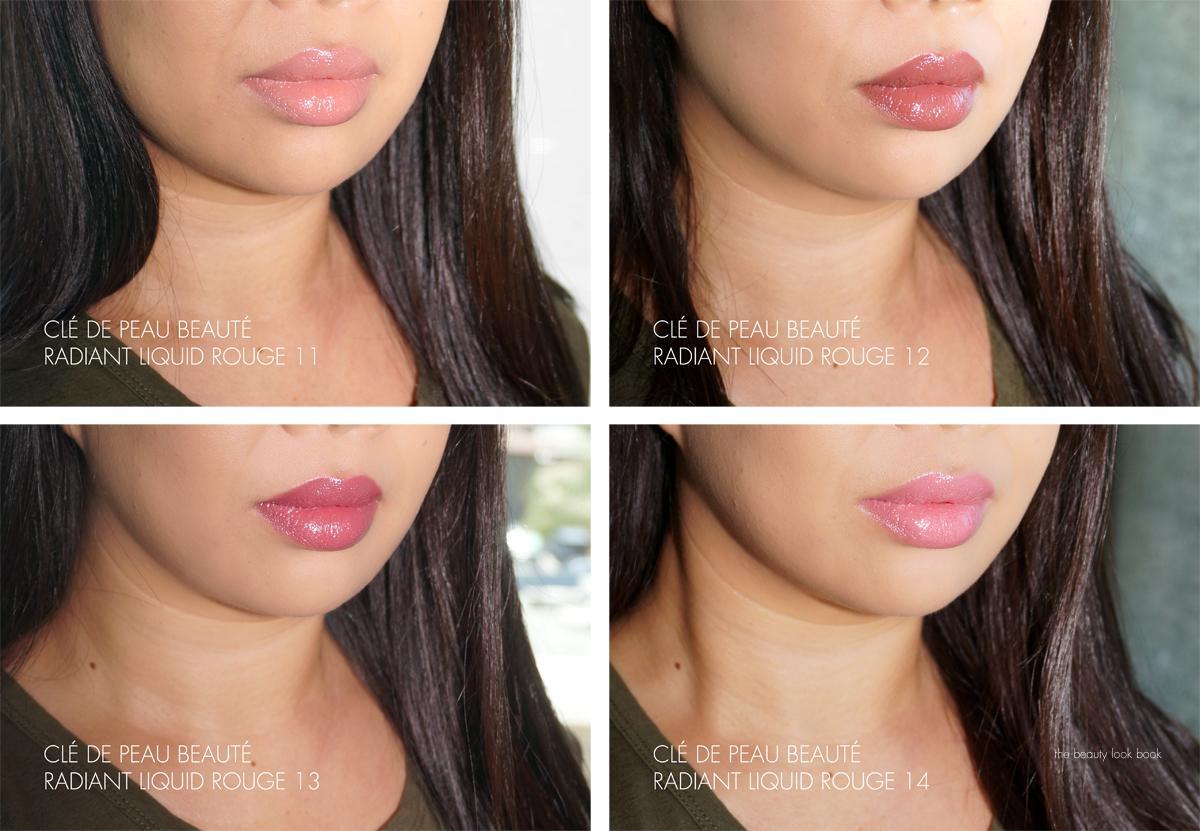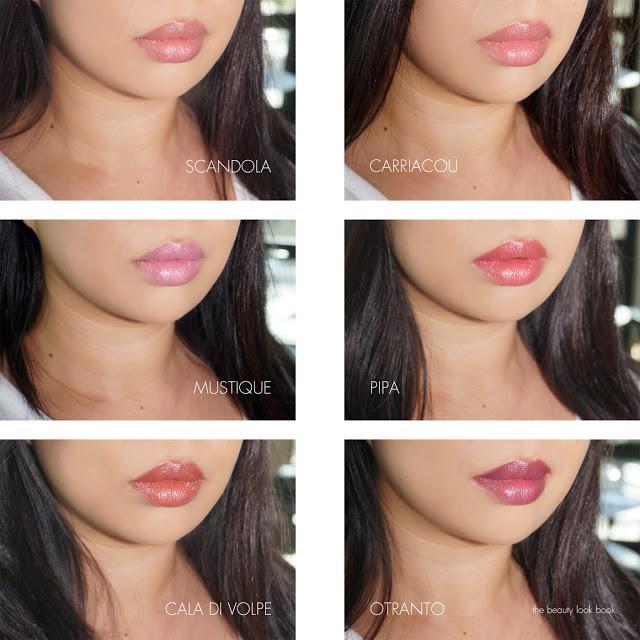The first image is the image on the left, the second image is the image on the right. For the images displayed, is the sentence "One photo is a closeup of tinted lips." factually correct? Answer yes or no. No. 